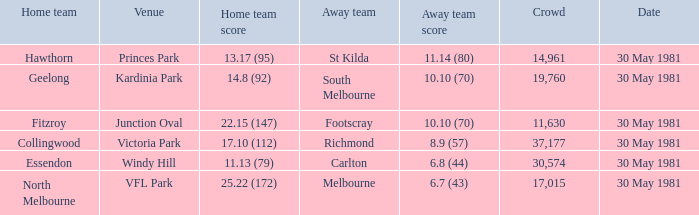What is the home venue of essendon with a crowd larger than 19,760? Windy Hill. 